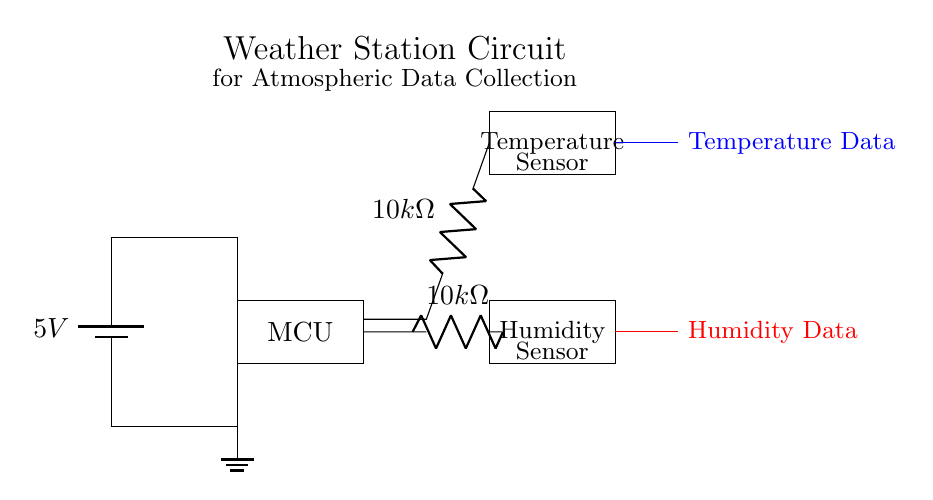What is the voltage of this circuit? The voltage is 5V, which is indicated by the battery symbol labeled with this voltage.
Answer: 5V What type of sensors are used in the circuit? The circuit includes a temperature sensor and a humidity sensor, as labeled in their respective rectangles.
Answer: Temperature and humidity sensors How many resistors are present in the circuit? There are two resistors, each labeled as 10k ohm, connecting the sensors to the microcontroller.
Answer: 2 What is the purpose of the microcontroller in this circuit? The microcontroller (MCU) is used to process the data from the temperature and humidity sensors, indicated by its central position in the circuit and its labeling as MCU.
Answer: Data processing What type of data does this circuit collect? The circuit collects atmospheric data, specifically temperature data and humidity data, as indicated by the labels next to the data lines.
Answer: Atmospheric data What is the current direction towards the humidity sensor? The current flows from the microcontroller through a resistor to the humidity sensor, based on the connection lines in the circuit diagram.
Answer: Toward humidity sensor Which components are powered by the 5V supply? The microcontroller, temperature sensor, and humidity sensor are all components powered by the 5V supply, as shown by the connections from the battery to these devices.
Answer: Microcontroller, temperature sensor, humidity sensor 